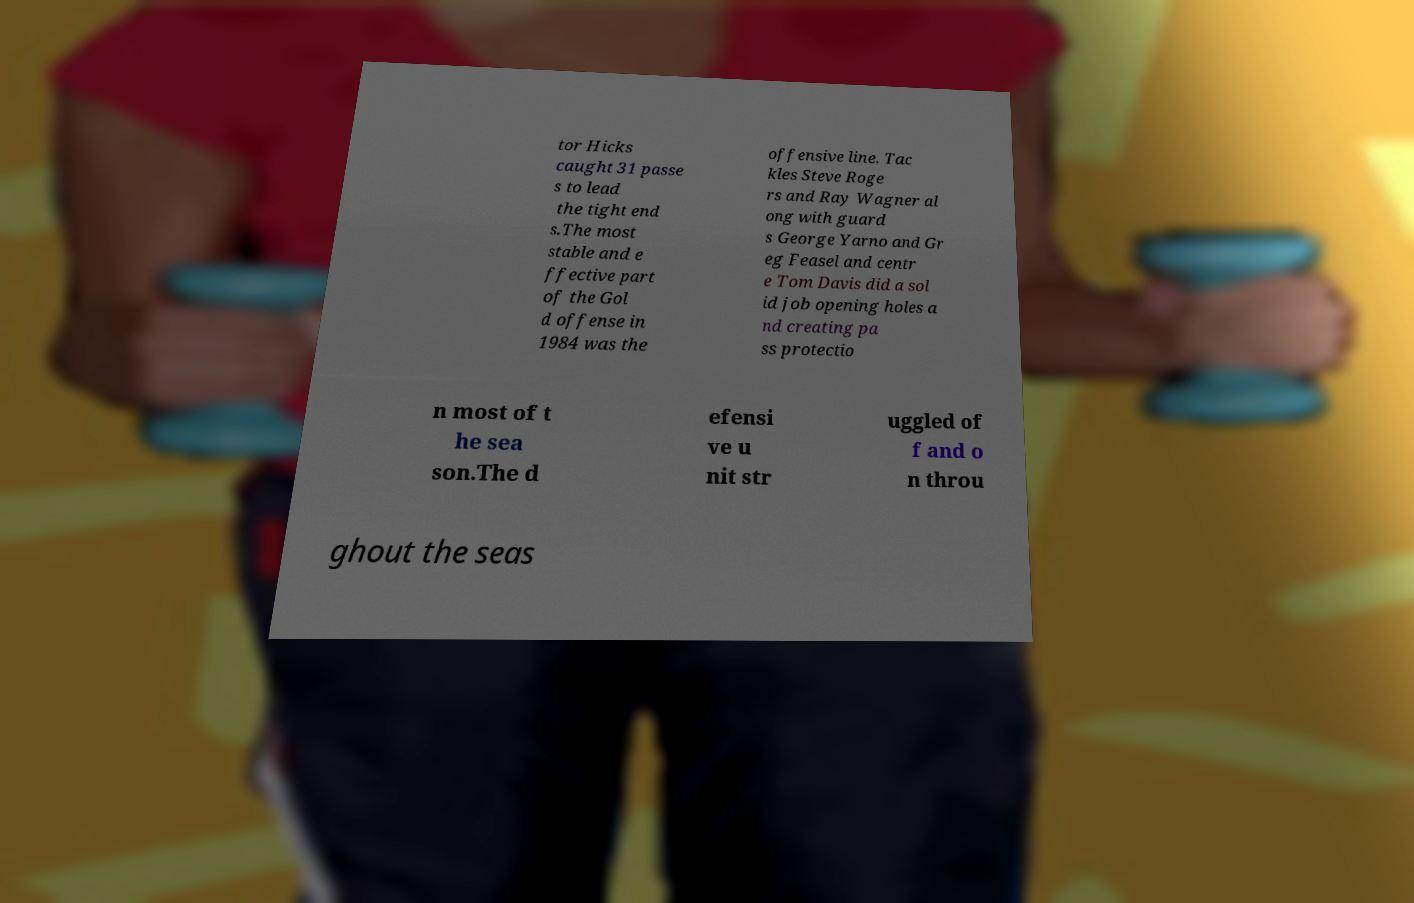Can you accurately transcribe the text from the provided image for me? tor Hicks caught 31 passe s to lead the tight end s.The most stable and e ffective part of the Gol d offense in 1984 was the offensive line. Tac kles Steve Roge rs and Ray Wagner al ong with guard s George Yarno and Gr eg Feasel and centr e Tom Davis did a sol id job opening holes a nd creating pa ss protectio n most of t he sea son.The d efensi ve u nit str uggled of f and o n throu ghout the seas 